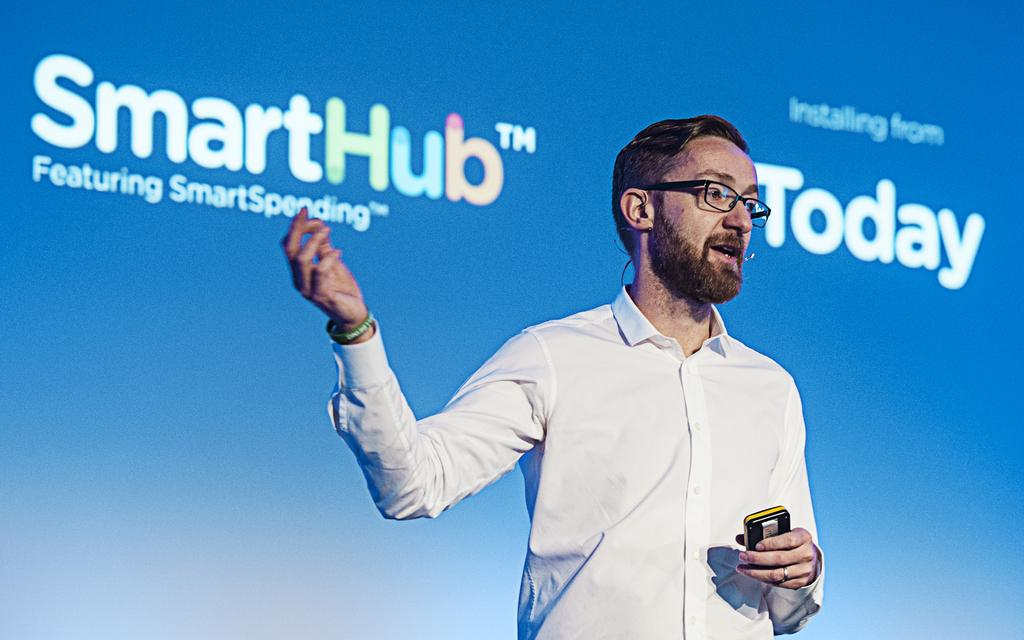What can be seen in the image? There is a person in the image. What is the person wearing? The person is wearing a white shirt. What is the person holding in his hand? The person is holding a mobile in his hand. What accessory is the person wearing? The person is wearing spectacles. What is visible in the background behind the person? There is a banner visible behind the person. What word is being smashed against the wall in the image? There is no word being smashed against a wall in the image. 